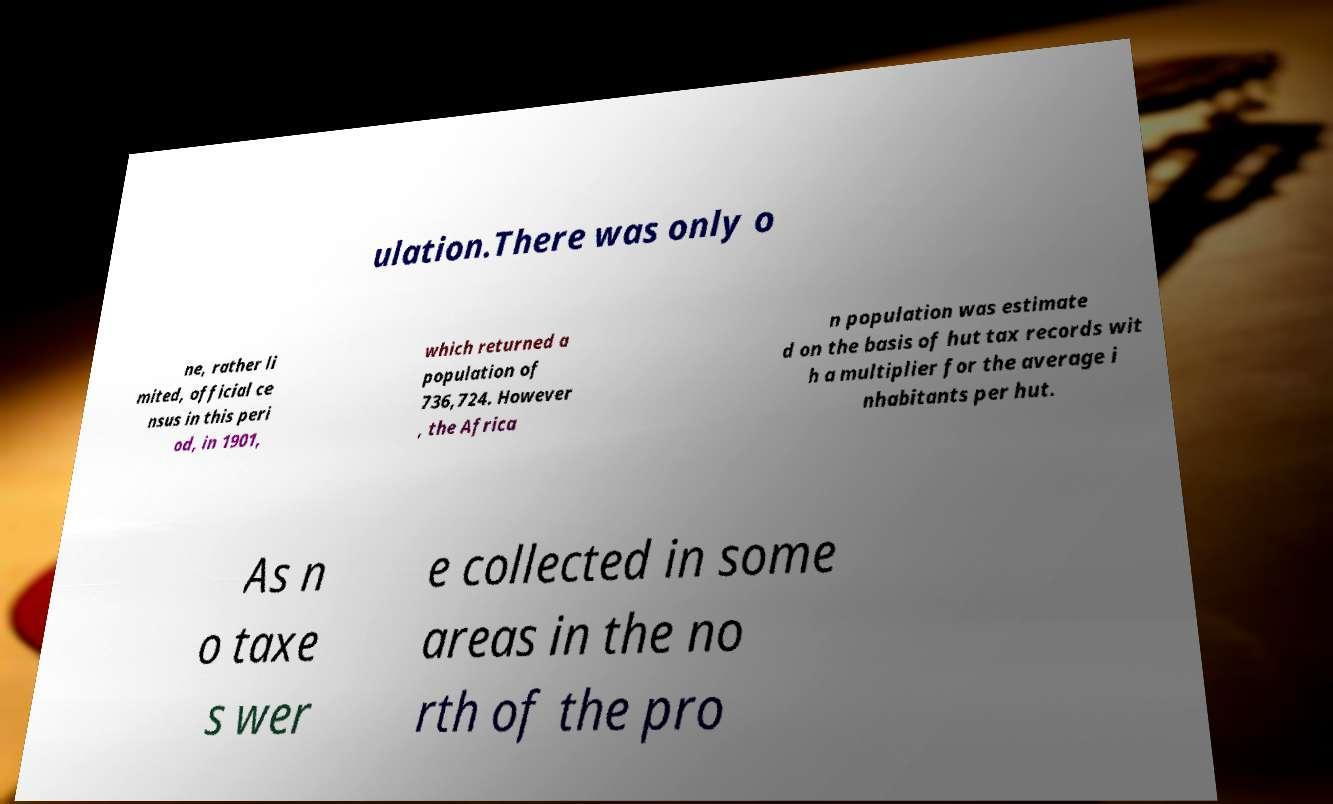Could you assist in decoding the text presented in this image and type it out clearly? ulation.There was only o ne, rather li mited, official ce nsus in this peri od, in 1901, which returned a population of 736,724. However , the Africa n population was estimate d on the basis of hut tax records wit h a multiplier for the average i nhabitants per hut. As n o taxe s wer e collected in some areas in the no rth of the pro 